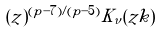<formula> <loc_0><loc_0><loc_500><loc_500>( z ) ^ { ( p - 7 ) / ( p - 5 ) } K _ { \nu } ( z k )</formula> 